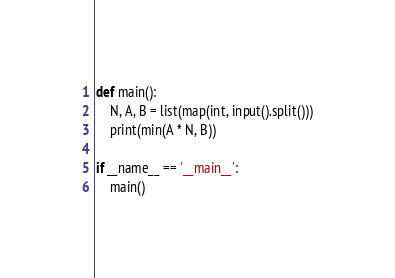<code> <loc_0><loc_0><loc_500><loc_500><_Python_>def main():
    N, A, B = list(map(int, input().split()))
    print(min(A * N, B))

if __name__ == '__main__':
    main()</code> 